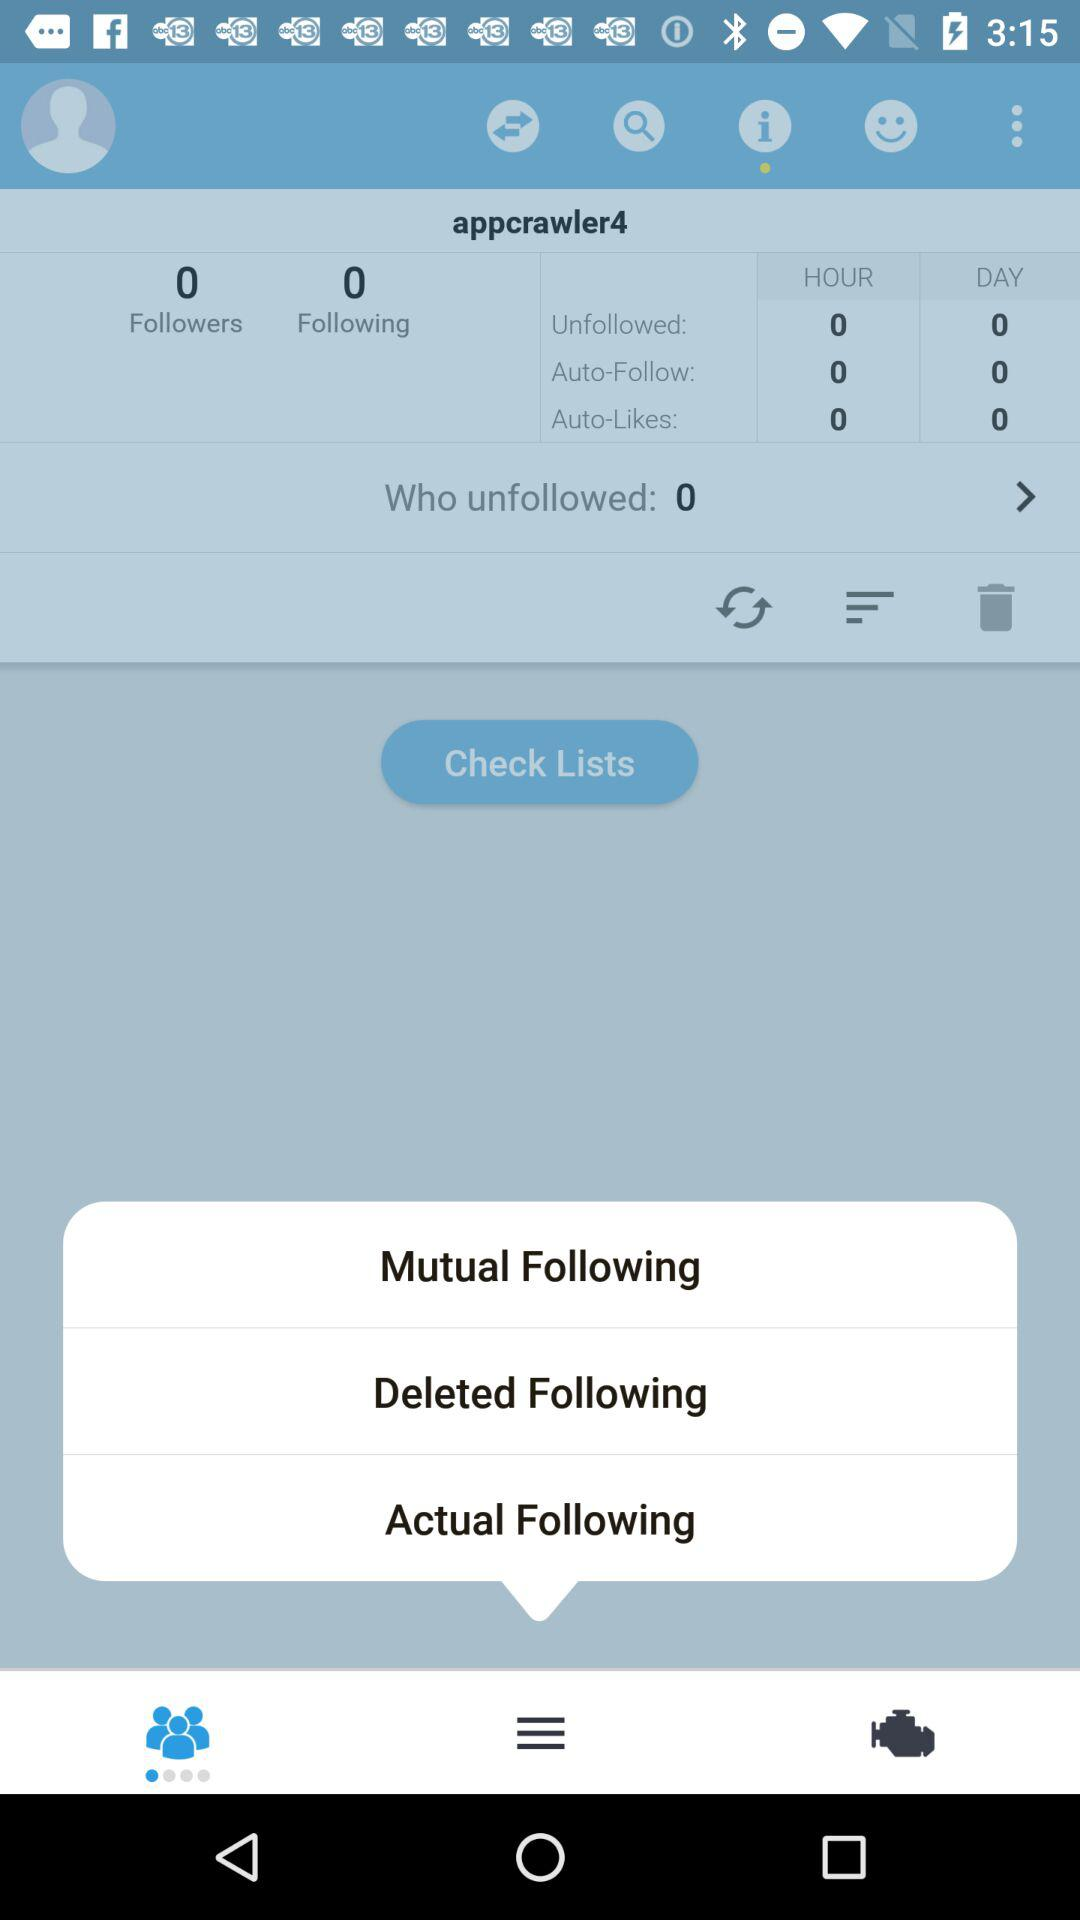How many people is "appcrawler4" following? "appcrawler4" is following 0 people. 